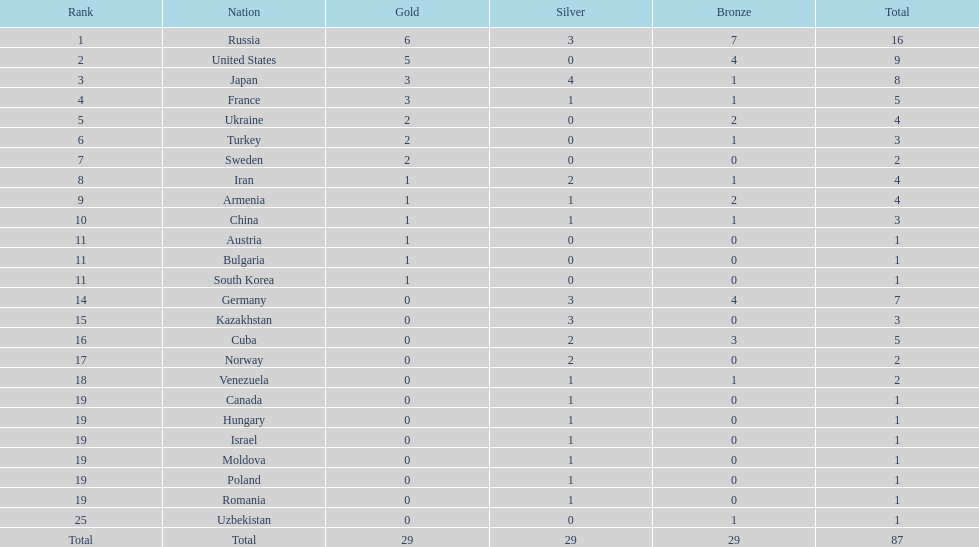Which country had the highest number of medals? Russia. 